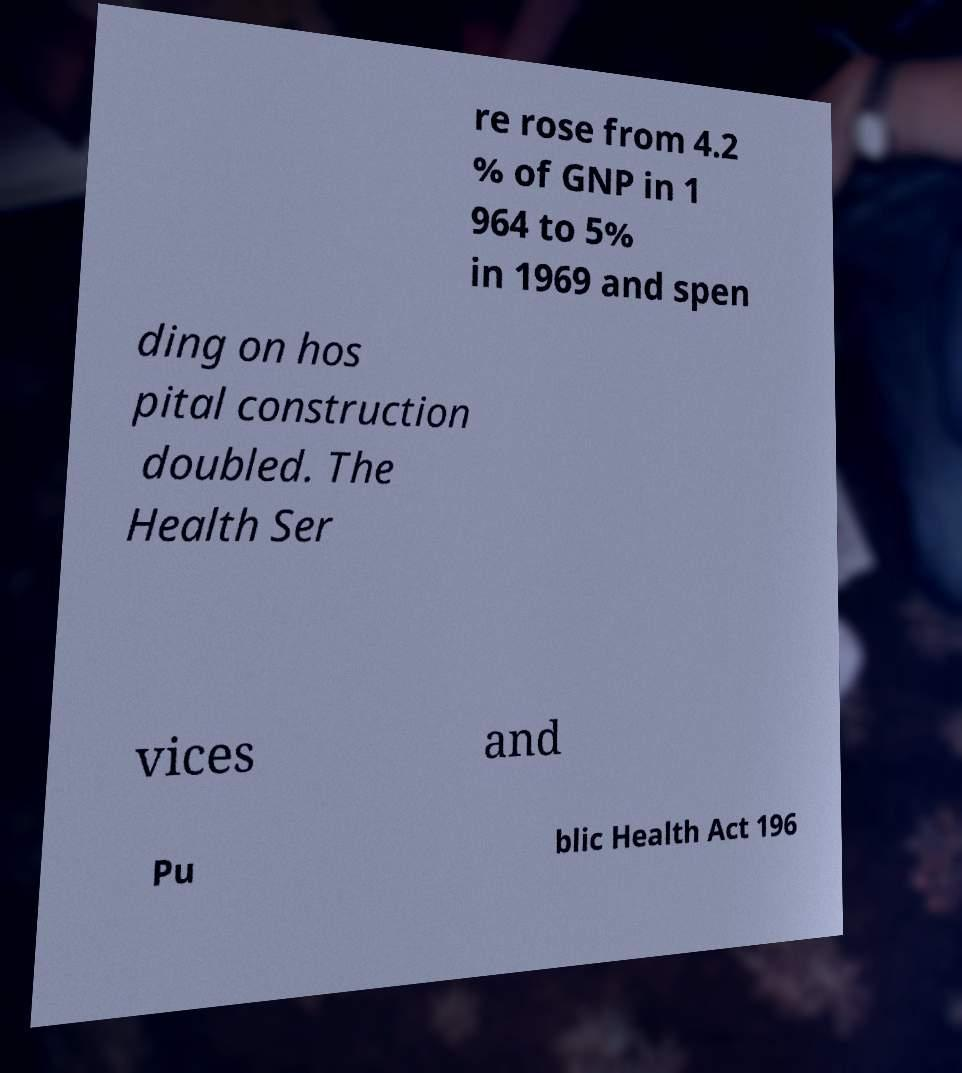For documentation purposes, I need the text within this image transcribed. Could you provide that? re rose from 4.2 % of GNP in 1 964 to 5% in 1969 and spen ding on hos pital construction doubled. The Health Ser vices and Pu blic Health Act 196 